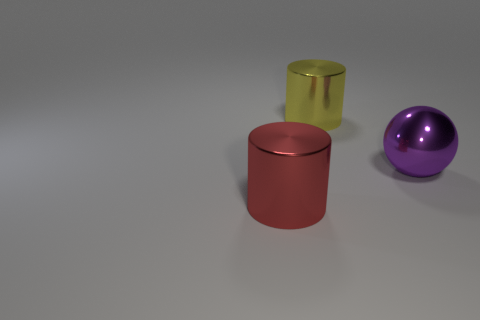Add 3 large objects. How many objects exist? 6 Subtract all balls. How many objects are left? 2 Add 1 big red cylinders. How many big red cylinders are left? 2 Add 1 red things. How many red things exist? 2 Subtract 1 red cylinders. How many objects are left? 2 Subtract all cyan metallic cylinders. Subtract all yellow metal objects. How many objects are left? 2 